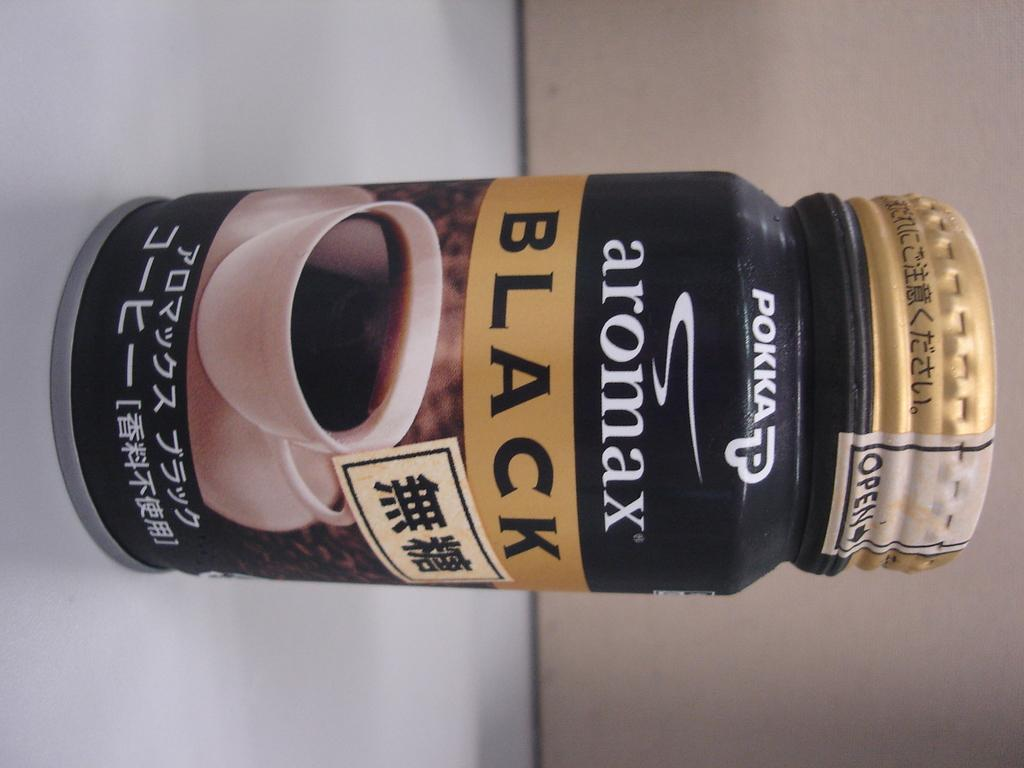<image>
Present a compact description of the photo's key features. a container of POKKA aromax BLACK coffee related item. 